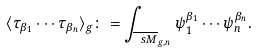<formula> <loc_0><loc_0><loc_500><loc_500>\langle \tau _ { \beta _ { 1 } } \cdots \tau _ { \beta _ { n } } \rangle _ { g } \colon = \int _ { \overline { \ s M } _ { g , n } } \psi ^ { \beta _ { 1 } } _ { 1 } \cdots \psi ^ { \beta _ { n } } _ { n } .</formula> 